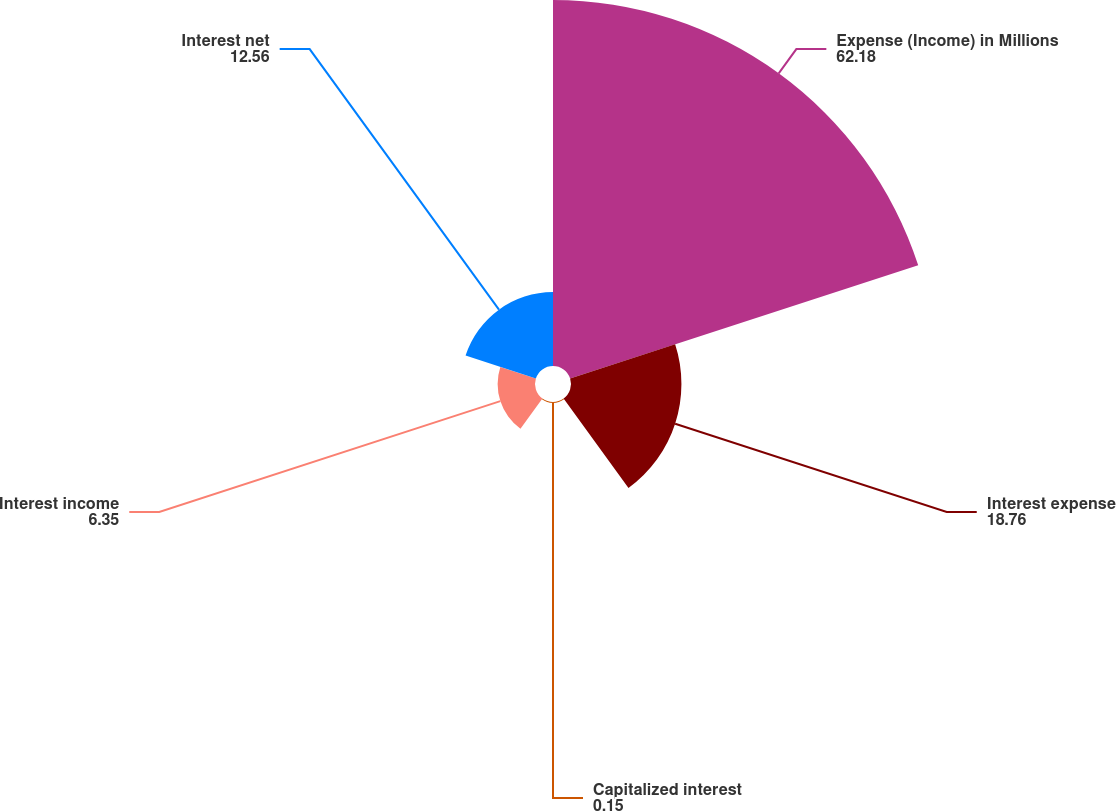<chart> <loc_0><loc_0><loc_500><loc_500><pie_chart><fcel>Expense (Income) in Millions<fcel>Interest expense<fcel>Capitalized interest<fcel>Interest income<fcel>Interest net<nl><fcel>62.18%<fcel>18.76%<fcel>0.15%<fcel>6.35%<fcel>12.56%<nl></chart> 